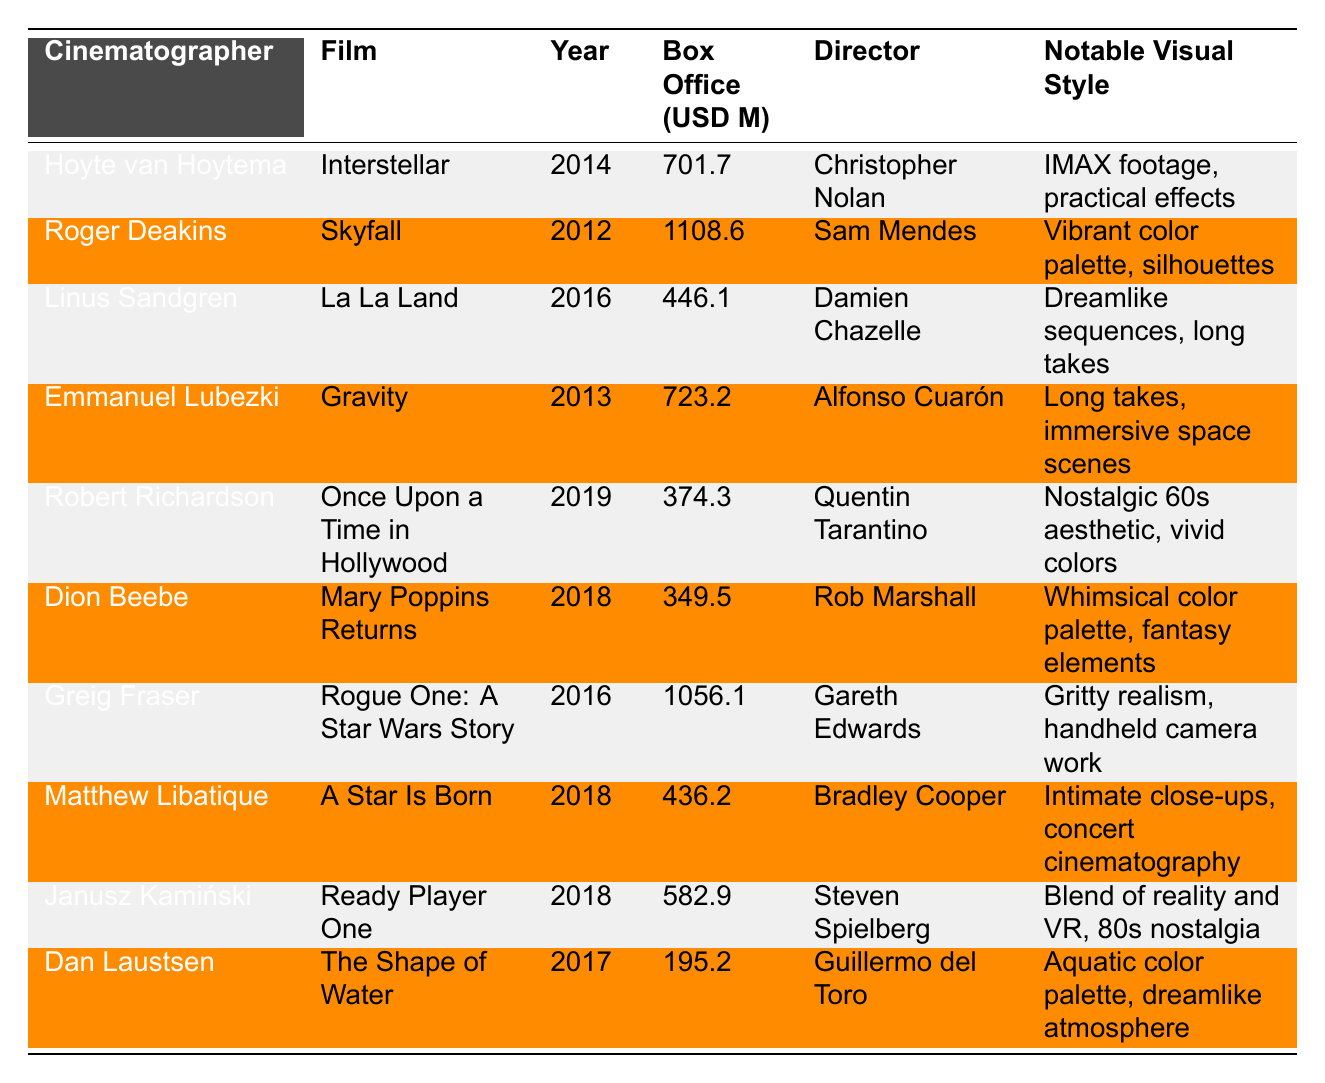What is the highest box office gross among the films listed? The table shows the box office gross for each film. By checking the values, "Skyfall" has the highest gross at 1108.6 million USD.
Answer: 1108.6 million USD Which film has a box office gross of 446.1 million USD? Looking through the box office figures in the table, "La La Land" corresponds to the value of 446.1 million USD.
Answer: La La Land Who is the cinematographer for "Interstellar"? In the table, the film "Interstellar" is associated with the cinematographer Hoyte van Hoytema.
Answer: Hoyte van Hoytema What year was "The Shape of Water" released? The table lists "The Shape of Water" with the release year of 2017.
Answer: 2017 Which film with a box office gross below 400 million USD has the earliest release year? The table shows "Once Upon a Time in Hollywood" (2019) and "Mary Poppins Returns" (2018) both below 400 million, but the earliest is "Mary Poppins Returns" at 2018.
Answer: Mary Poppins Returns What is the total box office gross of films shot by Roger Deakins? Roger Deakins shot "Skyfall" (1108.6 million USD) and had no other films listed, hence the total gross is solely from "Skyfall."
Answer: 1108.6 million USD Does any film noted in the table have a director also listed in conjunction with the cinematographer Robert Richardson? The table confirms that "Once Upon a Time in Hollywood," with Robert Richardson as cinematographer, has Quentin Tarantino as its director, therefore the answer is yes.
Answer: Yes What is the average box office gross of the films directed by Christopher Nolan? The only film listed directed by Christopher Nolan is "Interstellar," which has a gross of 701.7 million USD. The average is 701.7 million since there's only one film.
Answer: 701.7 million USD Which cinematographer has worked on films with the closest box office figures found in the table, and what are those figures? The closest figures are "Mary Poppins Returns" (349.5 million USD) and "Dion Beebe" is the cinematographer of that film.
Answer: Dion Beebe with 349.5 million USD How many films grossed over 700 million USD? Checking the box office figures listed, "Skyfall" (1108.6 million USD), "Gravity" (723.2 million USD), and "Interstellar" (701.7 million USD) grossed over 700 million USD. In total, there are three films.
Answer: 3 